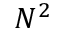<formula> <loc_0><loc_0><loc_500><loc_500>N ^ { 2 }</formula> 